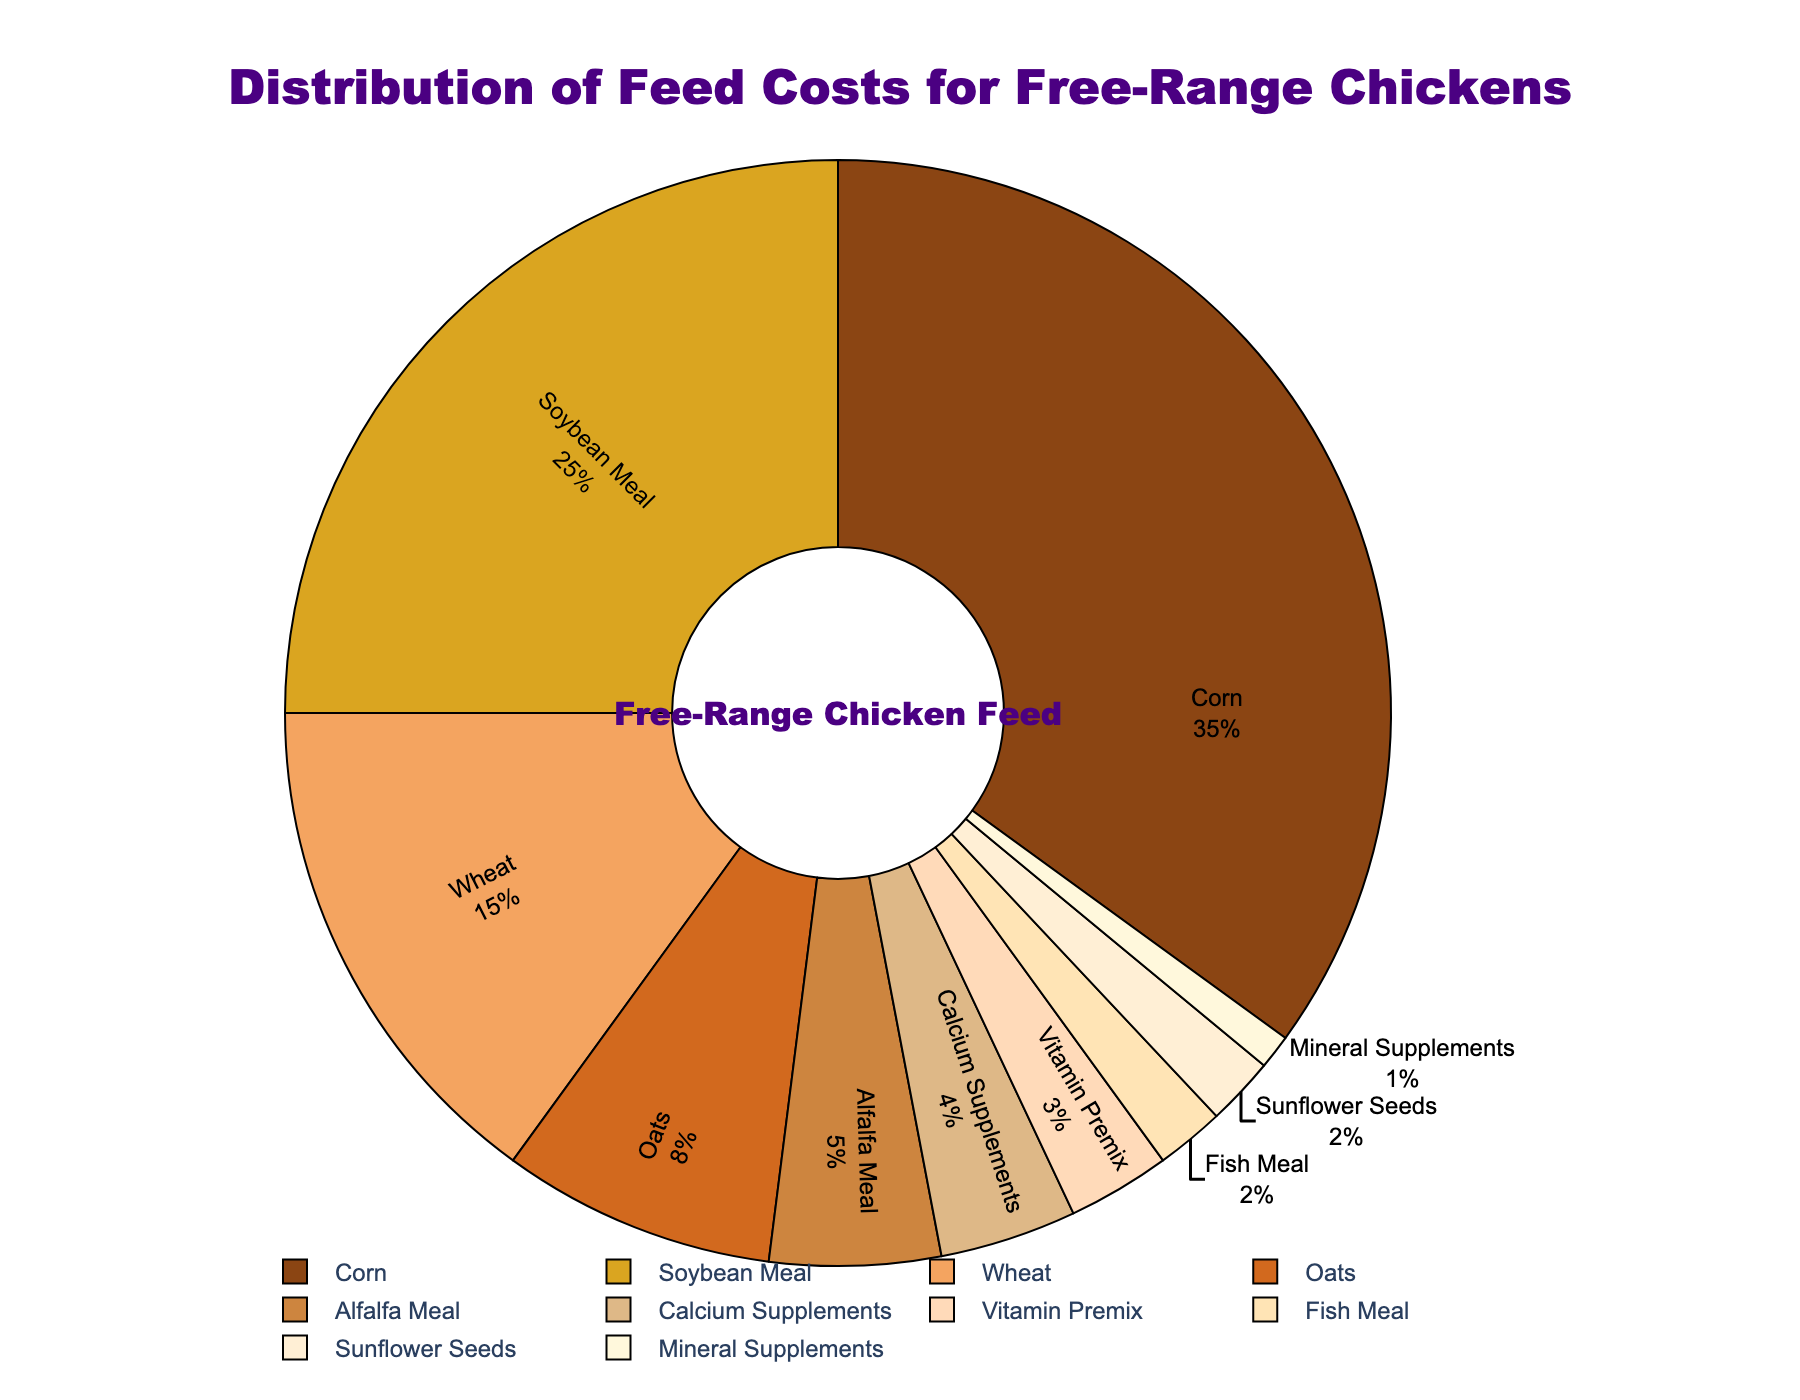What is the percentage of feed cost attributed to Corn? The percentage of feed cost for Corn is directly labeled on the pie chart.
Answer: 35% Which type of feed has the smallest contribution to the feed costs? By looking at the pie chart, the segment for Mineral Supplements is the smallest.
Answer: Mineral Supplements How does the feed cost for Soybean Meal compare to that of Wheat? From the chart, Soybean Meal accounts for 25% of the feed costs while Wheat accounts for 15%. Therefore, Soybean Meal has a larger contribution.
Answer: Soybean Meal What is the combined percentage of feed costs for Oats and Alfalfa Meal? According to the pie chart, Oats account for 8% and Alfalfa Meal accounts for 5%. Adding these together gives 8% + 5% = 13%.
Answer: 13% Of the feed types listed, which one costs less: Fish Meal or Sunflower Seeds? The pie chart shows that both Fish Meal and Sunflower Seeds each contribute 2% to the feed costs.
Answer: They cost the same What is the total percentage of feed costs attributed to supplements (Calcium and Mineral)? According to the chart, Calcium Supplements account for 4% and Mineral Supplements account for 1%. Summing these gives 4% + 1% = 5%.
Answer: 5% Which two feed types combined have a feed cost percentage equal to that of Corn? From the chart, Corn is 35%. By trial and error or observation, Soybean Meal (25%) and Wheat (15%) together make 25% + 15% = 40%. However, Soybean Meal and Oats together make 25% + 8%, which is only 33%. Consequently, no exact pair sums to Corn's percentage.
Answer: None Are there any feed types that make up less than 5% of the feed costs? If so, list them. The pie chart shows that the feed types making up less than 5% are Fish Meal, Sunflower Seeds, Vitamin Premix, Calcium Supplements, and Mineral Supplements.
Answer: Fish Meal, Sunflower Seeds, Vitamin Premix, Calcium Supplements, Mineral Supplements What percentage of feed costs is attributed to non-grain feed types? Grain feed types are Corn, Wheat, Oats, Soybean Meal, and Sunflower Seeds. Summing their contributions gives 35% + 15% + 8% + 25% + 2% = 85%. Consequently, the non-grain feed types make 100% - 85% = 15%.
Answer: 15% 